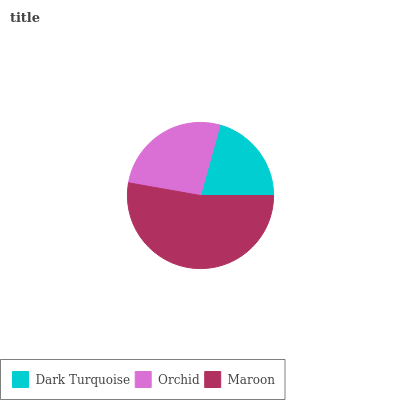Is Dark Turquoise the minimum?
Answer yes or no. Yes. Is Maroon the maximum?
Answer yes or no. Yes. Is Orchid the minimum?
Answer yes or no. No. Is Orchid the maximum?
Answer yes or no. No. Is Orchid greater than Dark Turquoise?
Answer yes or no. Yes. Is Dark Turquoise less than Orchid?
Answer yes or no. Yes. Is Dark Turquoise greater than Orchid?
Answer yes or no. No. Is Orchid less than Dark Turquoise?
Answer yes or no. No. Is Orchid the high median?
Answer yes or no. Yes. Is Orchid the low median?
Answer yes or no. Yes. Is Dark Turquoise the high median?
Answer yes or no. No. Is Maroon the low median?
Answer yes or no. No. 